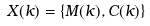<formula> <loc_0><loc_0><loc_500><loc_500>X ( k ) = \{ M ( k ) , C ( k ) \}</formula> 